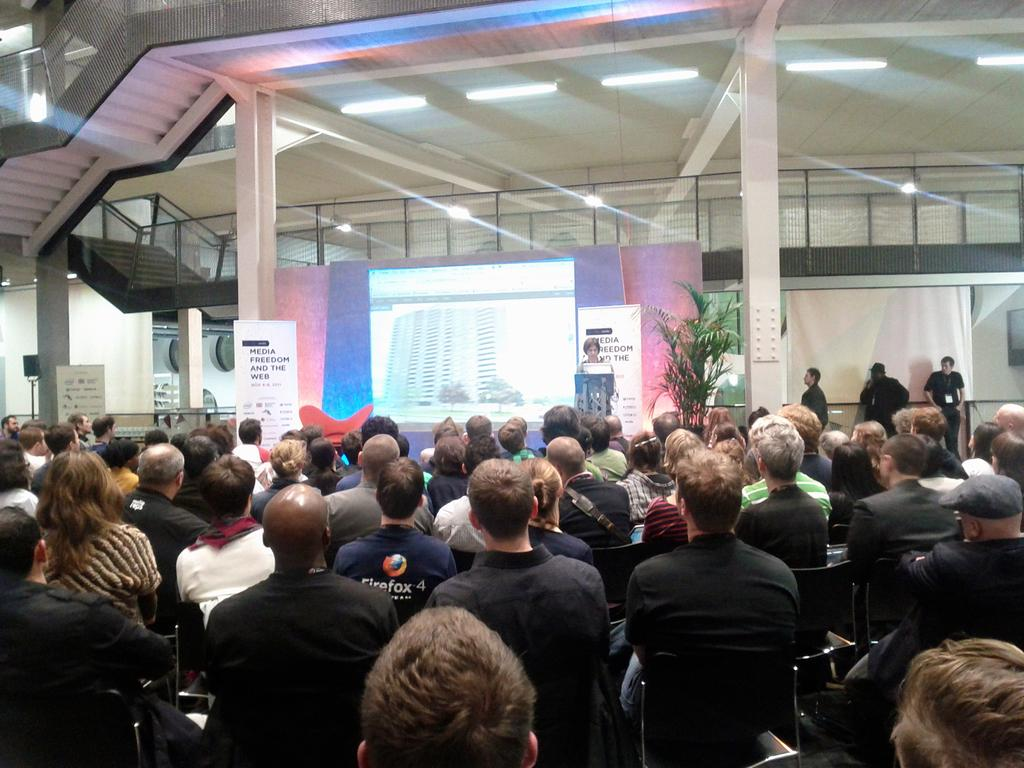What are the people in the image doing? The people in the image are sitting on chairs, and there is one person standing. What objects can be seen in the image? There are boards, pillars, and a plant visible in the image. What can be seen in the background of the image? In the background, there is a screen, people, steps, lights, and a wall. Where is the hydrant located in the image? There is no hydrant present in the image. What type of comb is being used by the person standing in the image? There is no comb visible in the image, as the person standing does not appear to be using one. 